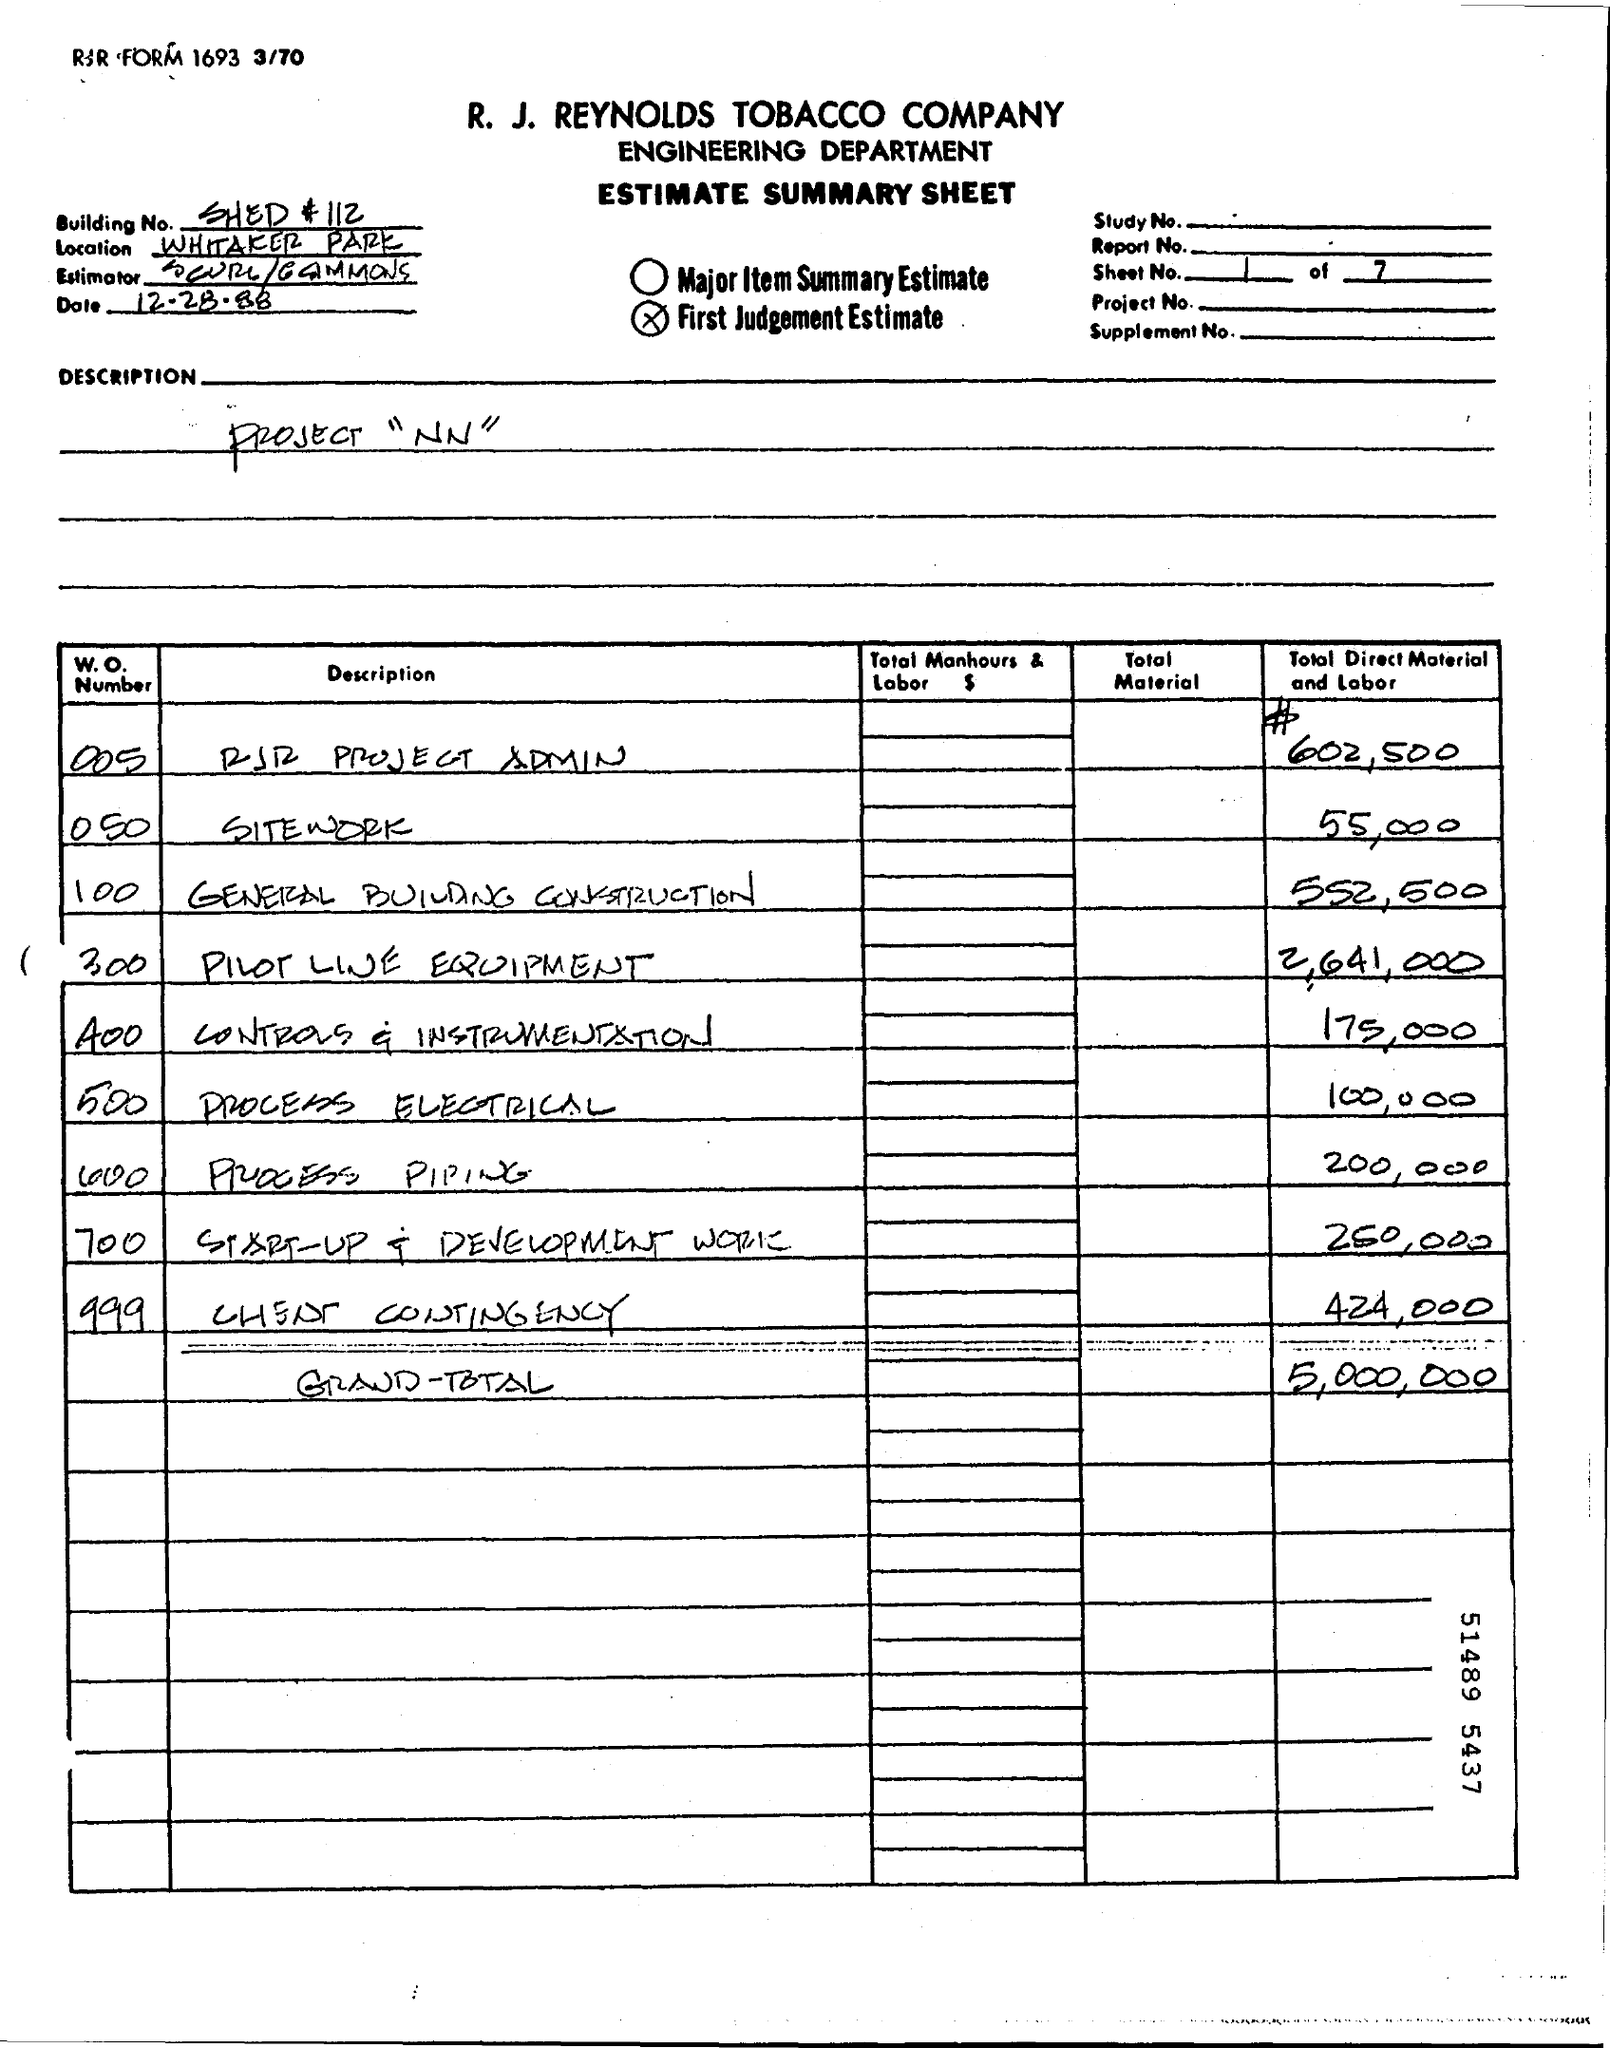What is the project name written this sheet
Offer a very short reply. Project "NN". 